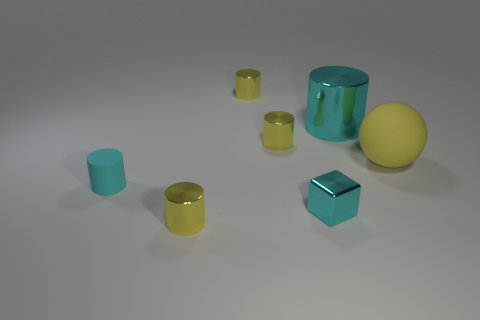Does the big shiny thing have the same shape as the cyan rubber object?
Provide a succinct answer. Yes. What number of small matte things are the same color as the large cylinder?
Your answer should be very brief. 1. What number of balls are large objects or big metal objects?
Give a very brief answer. 1. What color is the thing that is the same size as the cyan metal cylinder?
Your answer should be compact. Yellow. Are there any cyan shiny cubes that are right of the cyan thing that is left of the yellow object in front of the tiny cube?
Your answer should be compact. Yes. The cyan metal cylinder is what size?
Provide a short and direct response. Large. How many things are yellow cylinders or metallic objects?
Keep it short and to the point. 5. What color is the small cube that is made of the same material as the large cyan cylinder?
Your answer should be very brief. Cyan. There is a cyan metallic object that is behind the big yellow rubber object; is it the same shape as the small cyan rubber thing?
Offer a terse response. Yes. What number of things are either things that are in front of the big ball or matte objects that are on the left side of the tiny cyan metal cube?
Offer a very short reply. 3. 